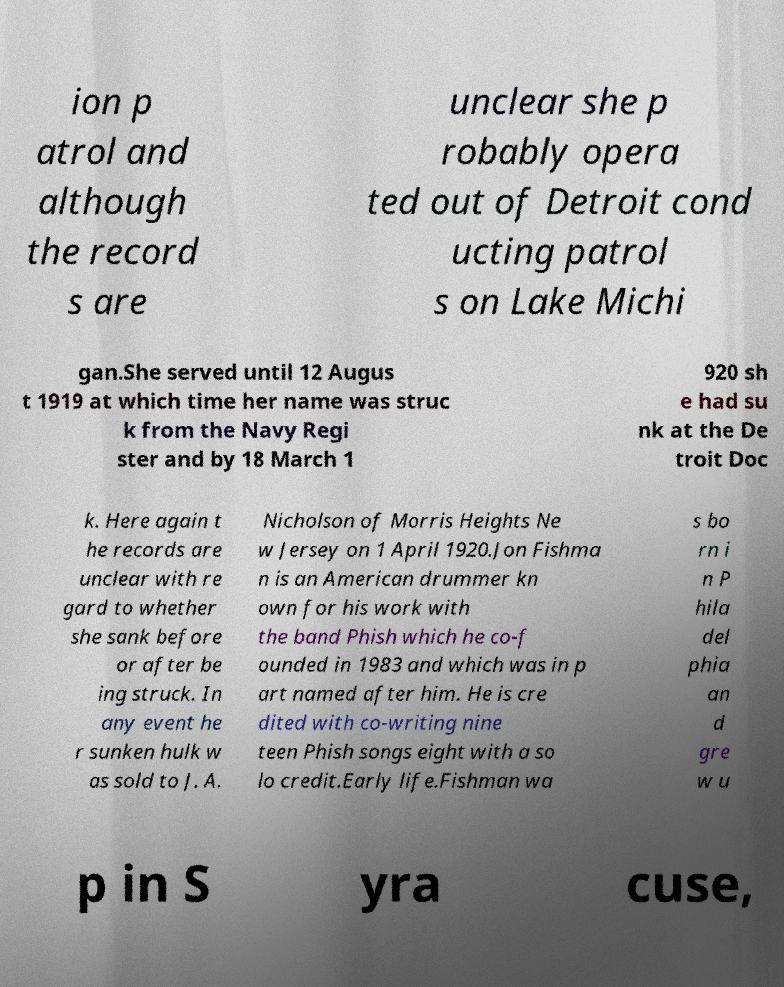What messages or text are displayed in this image? I need them in a readable, typed format. ion p atrol and although the record s are unclear she p robably opera ted out of Detroit cond ucting patrol s on Lake Michi gan.She served until 12 Augus t 1919 at which time her name was struc k from the Navy Regi ster and by 18 March 1 920 sh e had su nk at the De troit Doc k. Here again t he records are unclear with re gard to whether she sank before or after be ing struck. In any event he r sunken hulk w as sold to J. A. Nicholson of Morris Heights Ne w Jersey on 1 April 1920.Jon Fishma n is an American drummer kn own for his work with the band Phish which he co-f ounded in 1983 and which was in p art named after him. He is cre dited with co-writing nine teen Phish songs eight with a so lo credit.Early life.Fishman wa s bo rn i n P hila del phia an d gre w u p in S yra cuse, 